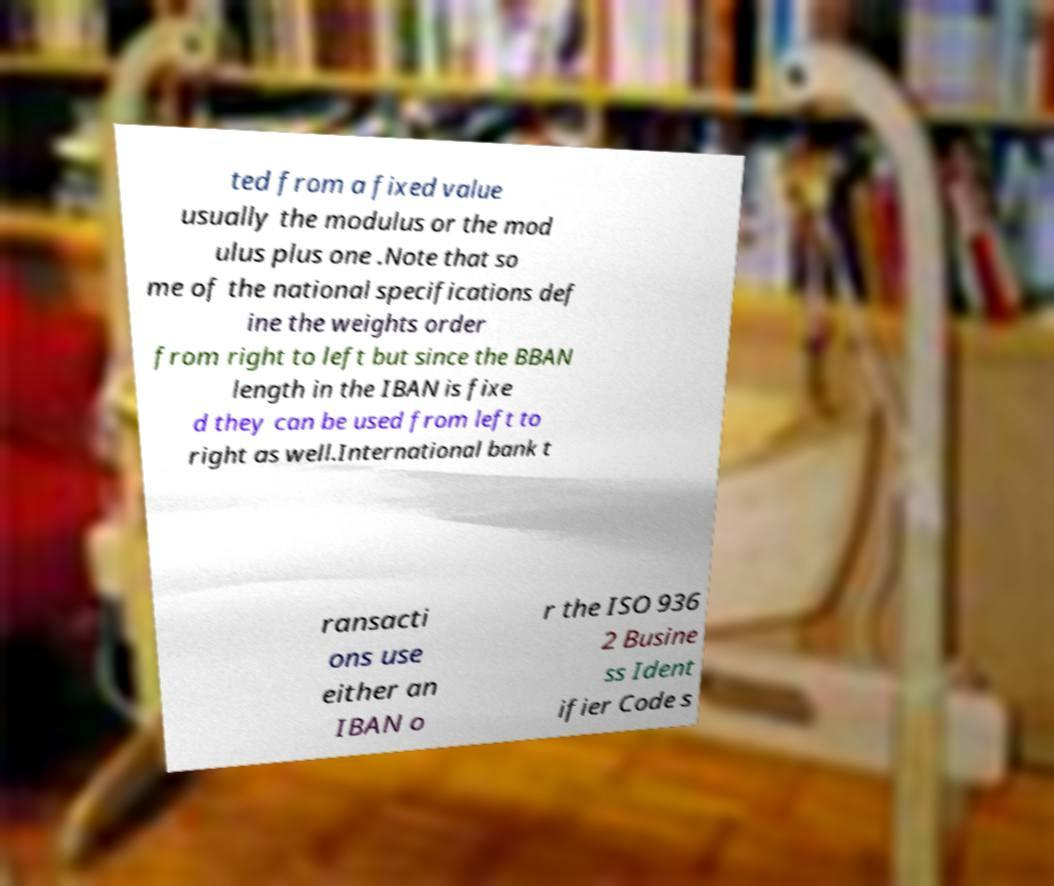Please read and relay the text visible in this image. What does it say? ted from a fixed value usually the modulus or the mod ulus plus one .Note that so me of the national specifications def ine the weights order from right to left but since the BBAN length in the IBAN is fixe d they can be used from left to right as well.International bank t ransacti ons use either an IBAN o r the ISO 936 2 Busine ss Ident ifier Code s 